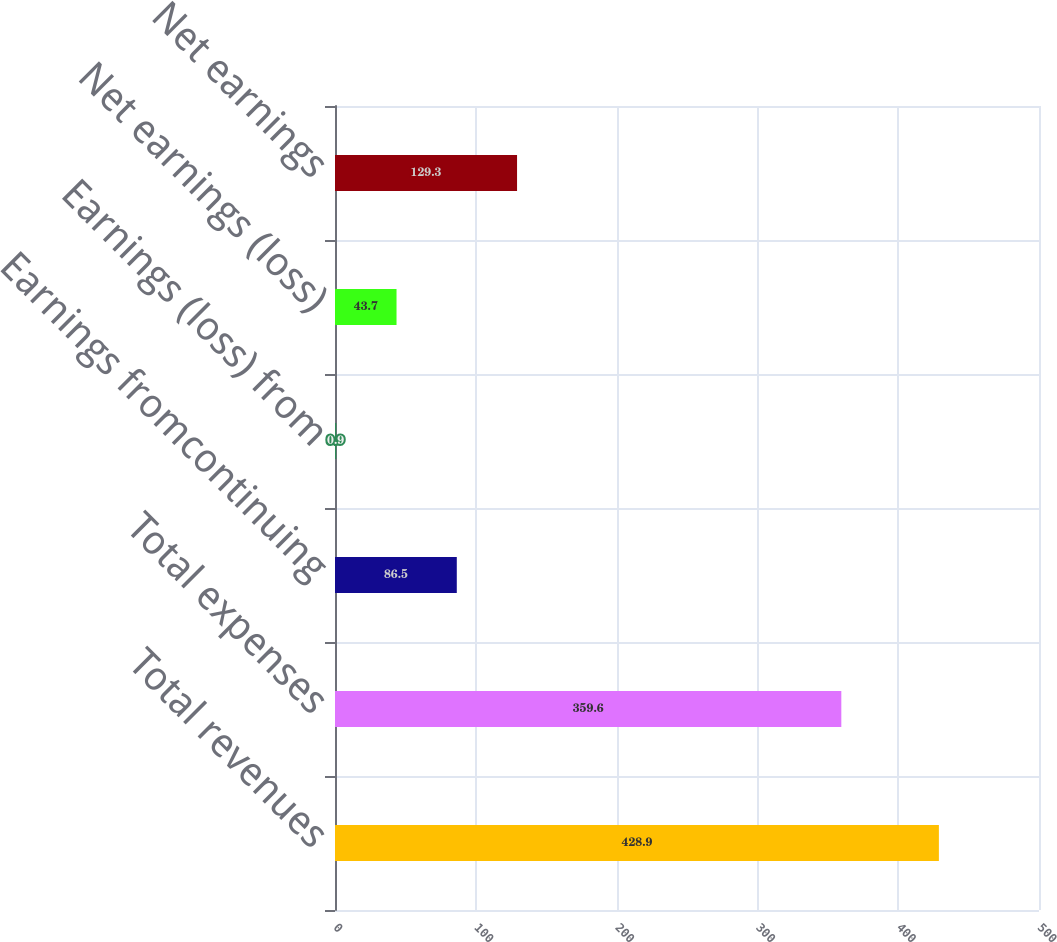Convert chart. <chart><loc_0><loc_0><loc_500><loc_500><bar_chart><fcel>Total revenues<fcel>Total expenses<fcel>Earnings fromcontinuing<fcel>Earnings (loss) from<fcel>Net earnings (loss)<fcel>Net earnings<nl><fcel>428.9<fcel>359.6<fcel>86.5<fcel>0.9<fcel>43.7<fcel>129.3<nl></chart> 